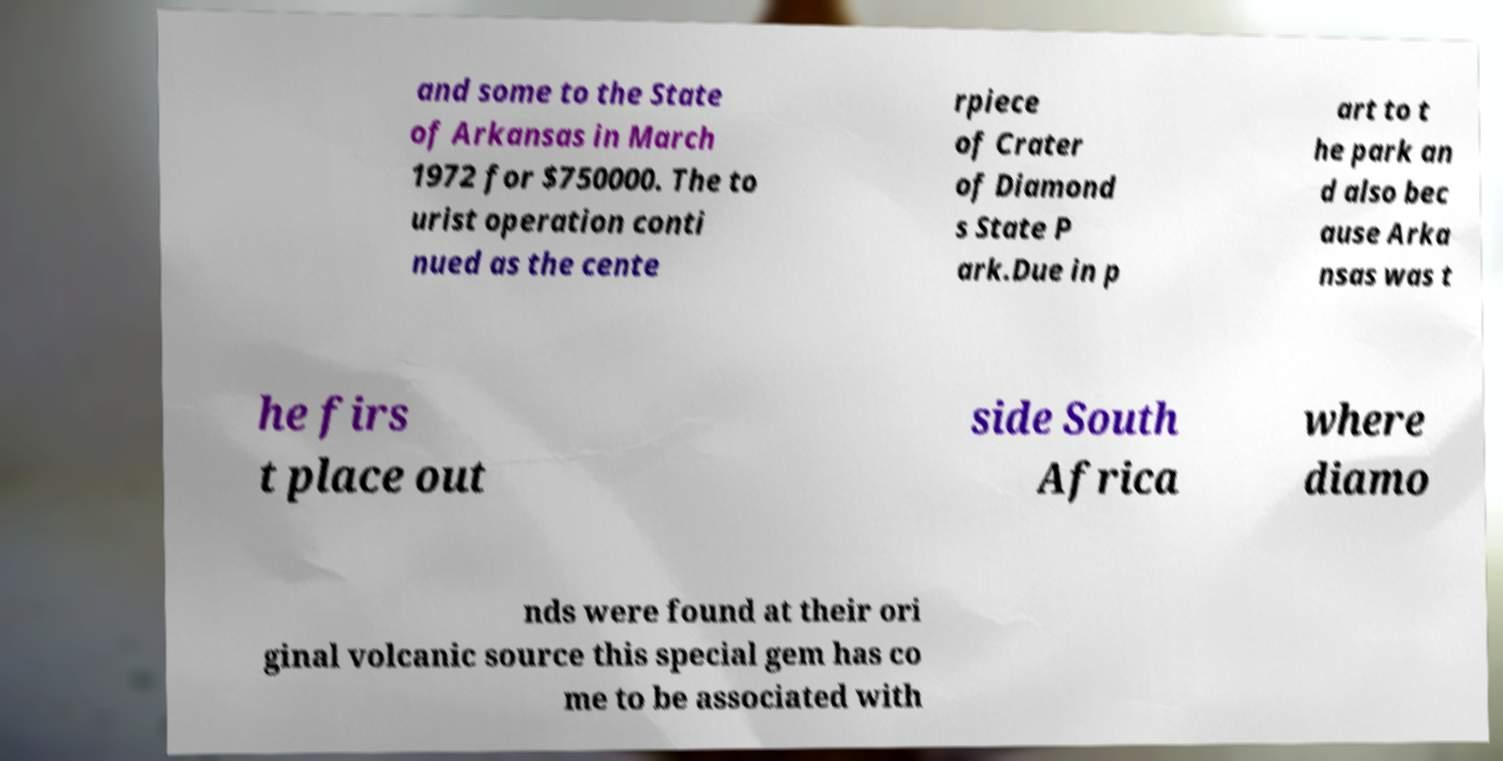Please identify and transcribe the text found in this image. and some to the State of Arkansas in March 1972 for $750000. The to urist operation conti nued as the cente rpiece of Crater of Diamond s State P ark.Due in p art to t he park an d also bec ause Arka nsas was t he firs t place out side South Africa where diamo nds were found at their ori ginal volcanic source this special gem has co me to be associated with 